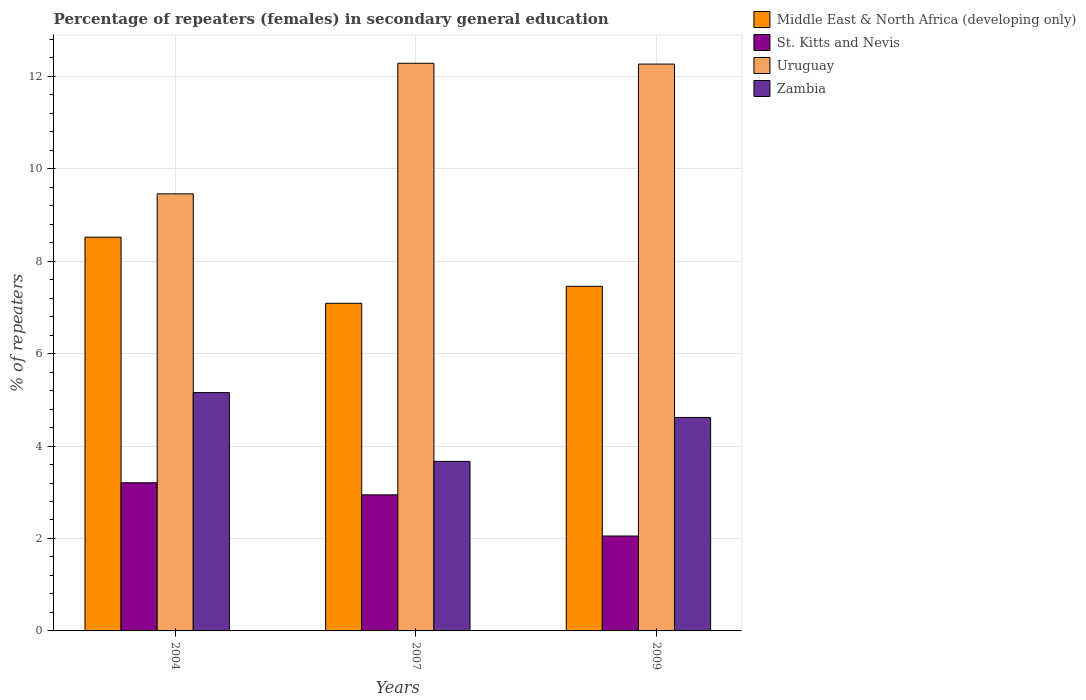What is the label of the 3rd group of bars from the left?
Provide a succinct answer. 2009. In how many cases, is the number of bars for a given year not equal to the number of legend labels?
Your answer should be very brief. 0. What is the percentage of female repeaters in Middle East & North Africa (developing only) in 2007?
Provide a short and direct response. 7.09. Across all years, what is the maximum percentage of female repeaters in Middle East & North Africa (developing only)?
Offer a very short reply. 8.52. Across all years, what is the minimum percentage of female repeaters in Zambia?
Offer a very short reply. 3.67. In which year was the percentage of female repeaters in Zambia maximum?
Give a very brief answer. 2004. What is the total percentage of female repeaters in Uruguay in the graph?
Your response must be concise. 34. What is the difference between the percentage of female repeaters in Uruguay in 2007 and that in 2009?
Give a very brief answer. 0.02. What is the difference between the percentage of female repeaters in Uruguay in 2007 and the percentage of female repeaters in St. Kitts and Nevis in 2009?
Offer a terse response. 10.23. What is the average percentage of female repeaters in St. Kitts and Nevis per year?
Ensure brevity in your answer.  2.73. In the year 2007, what is the difference between the percentage of female repeaters in St. Kitts and Nevis and percentage of female repeaters in Uruguay?
Ensure brevity in your answer.  -9.34. What is the ratio of the percentage of female repeaters in Middle East & North Africa (developing only) in 2004 to that in 2009?
Your answer should be very brief. 1.14. Is the percentage of female repeaters in St. Kitts and Nevis in 2004 less than that in 2007?
Offer a terse response. No. Is the difference between the percentage of female repeaters in St. Kitts and Nevis in 2007 and 2009 greater than the difference between the percentage of female repeaters in Uruguay in 2007 and 2009?
Ensure brevity in your answer.  Yes. What is the difference between the highest and the second highest percentage of female repeaters in Middle East & North Africa (developing only)?
Your response must be concise. 1.06. What is the difference between the highest and the lowest percentage of female repeaters in St. Kitts and Nevis?
Your answer should be compact. 1.15. In how many years, is the percentage of female repeaters in Uruguay greater than the average percentage of female repeaters in Uruguay taken over all years?
Ensure brevity in your answer.  2. Is the sum of the percentage of female repeaters in St. Kitts and Nevis in 2004 and 2009 greater than the maximum percentage of female repeaters in Middle East & North Africa (developing only) across all years?
Offer a very short reply. No. Is it the case that in every year, the sum of the percentage of female repeaters in Uruguay and percentage of female repeaters in St. Kitts and Nevis is greater than the sum of percentage of female repeaters in Zambia and percentage of female repeaters in Middle East & North Africa (developing only)?
Provide a short and direct response. No. What does the 2nd bar from the left in 2009 represents?
Offer a terse response. St. Kitts and Nevis. What does the 2nd bar from the right in 2007 represents?
Ensure brevity in your answer.  Uruguay. How many bars are there?
Offer a terse response. 12. Are all the bars in the graph horizontal?
Your answer should be very brief. No. What is the difference between two consecutive major ticks on the Y-axis?
Make the answer very short. 2. Are the values on the major ticks of Y-axis written in scientific E-notation?
Keep it short and to the point. No. Does the graph contain any zero values?
Provide a short and direct response. No. Where does the legend appear in the graph?
Give a very brief answer. Top right. What is the title of the graph?
Your answer should be compact. Percentage of repeaters (females) in secondary general education. What is the label or title of the X-axis?
Provide a short and direct response. Years. What is the label or title of the Y-axis?
Provide a succinct answer. % of repeaters. What is the % of repeaters in Middle East & North Africa (developing only) in 2004?
Keep it short and to the point. 8.52. What is the % of repeaters of St. Kitts and Nevis in 2004?
Provide a short and direct response. 3.21. What is the % of repeaters in Uruguay in 2004?
Ensure brevity in your answer.  9.46. What is the % of repeaters in Zambia in 2004?
Make the answer very short. 5.16. What is the % of repeaters in Middle East & North Africa (developing only) in 2007?
Offer a very short reply. 7.09. What is the % of repeaters of St. Kitts and Nevis in 2007?
Provide a succinct answer. 2.94. What is the % of repeaters of Uruguay in 2007?
Provide a short and direct response. 12.28. What is the % of repeaters in Zambia in 2007?
Provide a succinct answer. 3.67. What is the % of repeaters of Middle East & North Africa (developing only) in 2009?
Offer a very short reply. 7.46. What is the % of repeaters in St. Kitts and Nevis in 2009?
Give a very brief answer. 2.05. What is the % of repeaters in Uruguay in 2009?
Keep it short and to the point. 12.26. What is the % of repeaters in Zambia in 2009?
Keep it short and to the point. 4.62. Across all years, what is the maximum % of repeaters of Middle East & North Africa (developing only)?
Your answer should be compact. 8.52. Across all years, what is the maximum % of repeaters of St. Kitts and Nevis?
Give a very brief answer. 3.21. Across all years, what is the maximum % of repeaters in Uruguay?
Ensure brevity in your answer.  12.28. Across all years, what is the maximum % of repeaters in Zambia?
Your response must be concise. 5.16. Across all years, what is the minimum % of repeaters of Middle East & North Africa (developing only)?
Give a very brief answer. 7.09. Across all years, what is the minimum % of repeaters in St. Kitts and Nevis?
Keep it short and to the point. 2.05. Across all years, what is the minimum % of repeaters of Uruguay?
Keep it short and to the point. 9.46. Across all years, what is the minimum % of repeaters of Zambia?
Ensure brevity in your answer.  3.67. What is the total % of repeaters in Middle East & North Africa (developing only) in the graph?
Make the answer very short. 23.06. What is the total % of repeaters of St. Kitts and Nevis in the graph?
Your answer should be very brief. 8.2. What is the total % of repeaters of Uruguay in the graph?
Offer a very short reply. 34. What is the total % of repeaters in Zambia in the graph?
Provide a succinct answer. 13.44. What is the difference between the % of repeaters of Middle East & North Africa (developing only) in 2004 and that in 2007?
Make the answer very short. 1.43. What is the difference between the % of repeaters in St. Kitts and Nevis in 2004 and that in 2007?
Offer a very short reply. 0.26. What is the difference between the % of repeaters in Uruguay in 2004 and that in 2007?
Ensure brevity in your answer.  -2.83. What is the difference between the % of repeaters in Zambia in 2004 and that in 2007?
Provide a short and direct response. 1.49. What is the difference between the % of repeaters of Middle East & North Africa (developing only) in 2004 and that in 2009?
Give a very brief answer. 1.06. What is the difference between the % of repeaters in St. Kitts and Nevis in 2004 and that in 2009?
Provide a short and direct response. 1.15. What is the difference between the % of repeaters in Uruguay in 2004 and that in 2009?
Provide a succinct answer. -2.81. What is the difference between the % of repeaters in Zambia in 2004 and that in 2009?
Your response must be concise. 0.54. What is the difference between the % of repeaters of Middle East & North Africa (developing only) in 2007 and that in 2009?
Your answer should be very brief. -0.37. What is the difference between the % of repeaters in St. Kitts and Nevis in 2007 and that in 2009?
Offer a very short reply. 0.89. What is the difference between the % of repeaters in Uruguay in 2007 and that in 2009?
Give a very brief answer. 0.02. What is the difference between the % of repeaters in Zambia in 2007 and that in 2009?
Provide a short and direct response. -0.95. What is the difference between the % of repeaters of Middle East & North Africa (developing only) in 2004 and the % of repeaters of St. Kitts and Nevis in 2007?
Your answer should be very brief. 5.58. What is the difference between the % of repeaters of Middle East & North Africa (developing only) in 2004 and the % of repeaters of Uruguay in 2007?
Give a very brief answer. -3.76. What is the difference between the % of repeaters in Middle East & North Africa (developing only) in 2004 and the % of repeaters in Zambia in 2007?
Keep it short and to the point. 4.85. What is the difference between the % of repeaters of St. Kitts and Nevis in 2004 and the % of repeaters of Uruguay in 2007?
Your answer should be very brief. -9.08. What is the difference between the % of repeaters in St. Kitts and Nevis in 2004 and the % of repeaters in Zambia in 2007?
Make the answer very short. -0.46. What is the difference between the % of repeaters of Uruguay in 2004 and the % of repeaters of Zambia in 2007?
Ensure brevity in your answer.  5.79. What is the difference between the % of repeaters of Middle East & North Africa (developing only) in 2004 and the % of repeaters of St. Kitts and Nevis in 2009?
Ensure brevity in your answer.  6.47. What is the difference between the % of repeaters in Middle East & North Africa (developing only) in 2004 and the % of repeaters in Uruguay in 2009?
Your answer should be compact. -3.75. What is the difference between the % of repeaters in Middle East & North Africa (developing only) in 2004 and the % of repeaters in Zambia in 2009?
Provide a succinct answer. 3.9. What is the difference between the % of repeaters of St. Kitts and Nevis in 2004 and the % of repeaters of Uruguay in 2009?
Your answer should be very brief. -9.06. What is the difference between the % of repeaters of St. Kitts and Nevis in 2004 and the % of repeaters of Zambia in 2009?
Offer a very short reply. -1.41. What is the difference between the % of repeaters in Uruguay in 2004 and the % of repeaters in Zambia in 2009?
Give a very brief answer. 4.84. What is the difference between the % of repeaters in Middle East & North Africa (developing only) in 2007 and the % of repeaters in St. Kitts and Nevis in 2009?
Offer a very short reply. 5.03. What is the difference between the % of repeaters of Middle East & North Africa (developing only) in 2007 and the % of repeaters of Uruguay in 2009?
Your answer should be very brief. -5.18. What is the difference between the % of repeaters of Middle East & North Africa (developing only) in 2007 and the % of repeaters of Zambia in 2009?
Provide a short and direct response. 2.47. What is the difference between the % of repeaters in St. Kitts and Nevis in 2007 and the % of repeaters in Uruguay in 2009?
Ensure brevity in your answer.  -9.32. What is the difference between the % of repeaters in St. Kitts and Nevis in 2007 and the % of repeaters in Zambia in 2009?
Offer a terse response. -1.68. What is the difference between the % of repeaters of Uruguay in 2007 and the % of repeaters of Zambia in 2009?
Your answer should be compact. 7.66. What is the average % of repeaters in Middle East & North Africa (developing only) per year?
Provide a short and direct response. 7.69. What is the average % of repeaters of St. Kitts and Nevis per year?
Offer a very short reply. 2.73. What is the average % of repeaters in Uruguay per year?
Ensure brevity in your answer.  11.33. What is the average % of repeaters of Zambia per year?
Your answer should be compact. 4.48. In the year 2004, what is the difference between the % of repeaters in Middle East & North Africa (developing only) and % of repeaters in St. Kitts and Nevis?
Provide a short and direct response. 5.31. In the year 2004, what is the difference between the % of repeaters of Middle East & North Africa (developing only) and % of repeaters of Uruguay?
Offer a terse response. -0.94. In the year 2004, what is the difference between the % of repeaters in Middle East & North Africa (developing only) and % of repeaters in Zambia?
Your answer should be compact. 3.36. In the year 2004, what is the difference between the % of repeaters in St. Kitts and Nevis and % of repeaters in Uruguay?
Ensure brevity in your answer.  -6.25. In the year 2004, what is the difference between the % of repeaters in St. Kitts and Nevis and % of repeaters in Zambia?
Provide a succinct answer. -1.95. In the year 2004, what is the difference between the % of repeaters of Uruguay and % of repeaters of Zambia?
Make the answer very short. 4.3. In the year 2007, what is the difference between the % of repeaters in Middle East & North Africa (developing only) and % of repeaters in St. Kitts and Nevis?
Keep it short and to the point. 4.14. In the year 2007, what is the difference between the % of repeaters of Middle East & North Africa (developing only) and % of repeaters of Uruguay?
Ensure brevity in your answer.  -5.19. In the year 2007, what is the difference between the % of repeaters of Middle East & North Africa (developing only) and % of repeaters of Zambia?
Your answer should be compact. 3.42. In the year 2007, what is the difference between the % of repeaters of St. Kitts and Nevis and % of repeaters of Uruguay?
Give a very brief answer. -9.34. In the year 2007, what is the difference between the % of repeaters of St. Kitts and Nevis and % of repeaters of Zambia?
Make the answer very short. -0.72. In the year 2007, what is the difference between the % of repeaters of Uruguay and % of repeaters of Zambia?
Offer a very short reply. 8.61. In the year 2009, what is the difference between the % of repeaters in Middle East & North Africa (developing only) and % of repeaters in St. Kitts and Nevis?
Offer a very short reply. 5.4. In the year 2009, what is the difference between the % of repeaters in Middle East & North Africa (developing only) and % of repeaters in Uruguay?
Your answer should be compact. -4.81. In the year 2009, what is the difference between the % of repeaters in Middle East & North Africa (developing only) and % of repeaters in Zambia?
Your answer should be compact. 2.84. In the year 2009, what is the difference between the % of repeaters of St. Kitts and Nevis and % of repeaters of Uruguay?
Your answer should be very brief. -10.21. In the year 2009, what is the difference between the % of repeaters in St. Kitts and Nevis and % of repeaters in Zambia?
Your answer should be compact. -2.57. In the year 2009, what is the difference between the % of repeaters in Uruguay and % of repeaters in Zambia?
Offer a very short reply. 7.65. What is the ratio of the % of repeaters of Middle East & North Africa (developing only) in 2004 to that in 2007?
Give a very brief answer. 1.2. What is the ratio of the % of repeaters of St. Kitts and Nevis in 2004 to that in 2007?
Keep it short and to the point. 1.09. What is the ratio of the % of repeaters in Uruguay in 2004 to that in 2007?
Your response must be concise. 0.77. What is the ratio of the % of repeaters of Zambia in 2004 to that in 2007?
Keep it short and to the point. 1.41. What is the ratio of the % of repeaters of Middle East & North Africa (developing only) in 2004 to that in 2009?
Make the answer very short. 1.14. What is the ratio of the % of repeaters in St. Kitts and Nevis in 2004 to that in 2009?
Offer a terse response. 1.56. What is the ratio of the % of repeaters in Uruguay in 2004 to that in 2009?
Keep it short and to the point. 0.77. What is the ratio of the % of repeaters in Zambia in 2004 to that in 2009?
Your answer should be compact. 1.12. What is the ratio of the % of repeaters in Middle East & North Africa (developing only) in 2007 to that in 2009?
Provide a short and direct response. 0.95. What is the ratio of the % of repeaters of St. Kitts and Nevis in 2007 to that in 2009?
Offer a terse response. 1.43. What is the ratio of the % of repeaters in Uruguay in 2007 to that in 2009?
Provide a succinct answer. 1. What is the ratio of the % of repeaters in Zambia in 2007 to that in 2009?
Provide a succinct answer. 0.79. What is the difference between the highest and the second highest % of repeaters of Middle East & North Africa (developing only)?
Keep it short and to the point. 1.06. What is the difference between the highest and the second highest % of repeaters in St. Kitts and Nevis?
Give a very brief answer. 0.26. What is the difference between the highest and the second highest % of repeaters in Uruguay?
Offer a very short reply. 0.02. What is the difference between the highest and the second highest % of repeaters of Zambia?
Your response must be concise. 0.54. What is the difference between the highest and the lowest % of repeaters of Middle East & North Africa (developing only)?
Your answer should be compact. 1.43. What is the difference between the highest and the lowest % of repeaters of St. Kitts and Nevis?
Your answer should be very brief. 1.15. What is the difference between the highest and the lowest % of repeaters in Uruguay?
Ensure brevity in your answer.  2.83. What is the difference between the highest and the lowest % of repeaters in Zambia?
Make the answer very short. 1.49. 